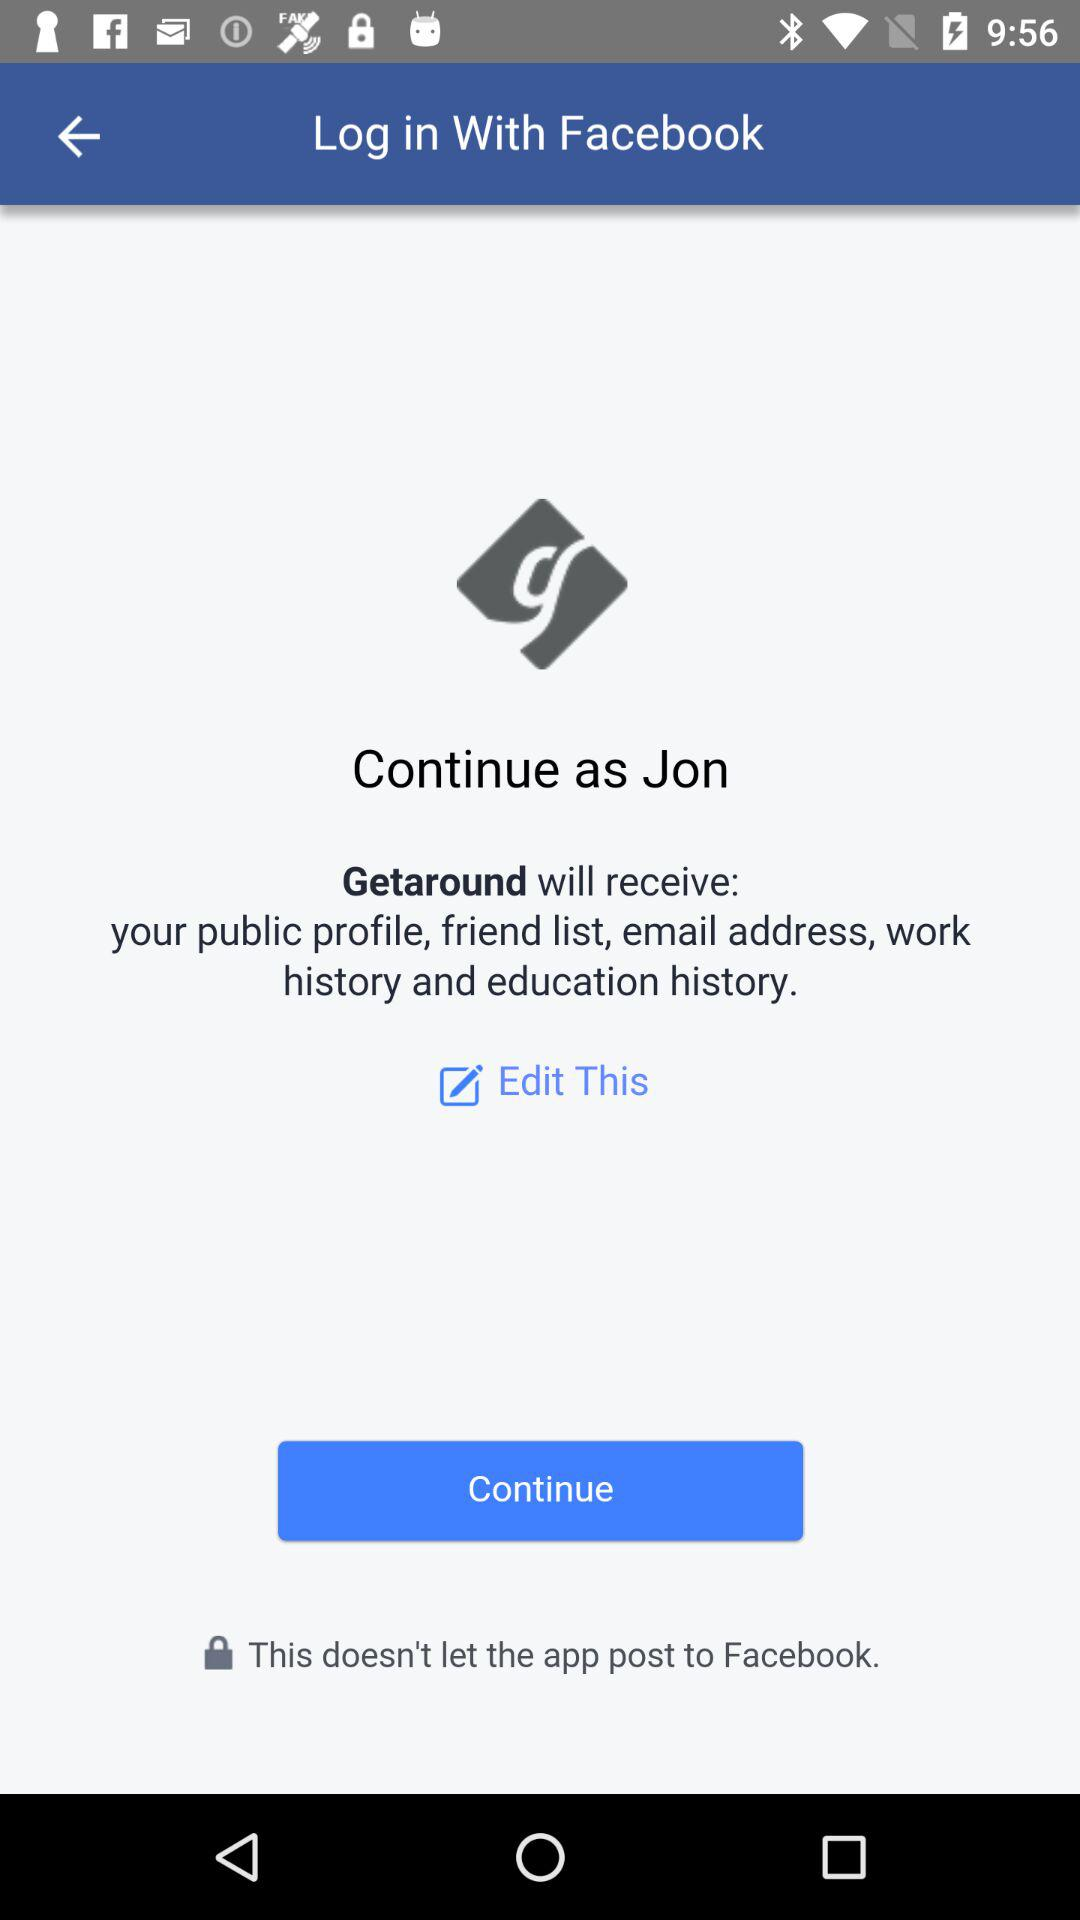Which email address will "Getaround" have access to?
When the provided information is insufficient, respond with <no answer>. <no answer> 